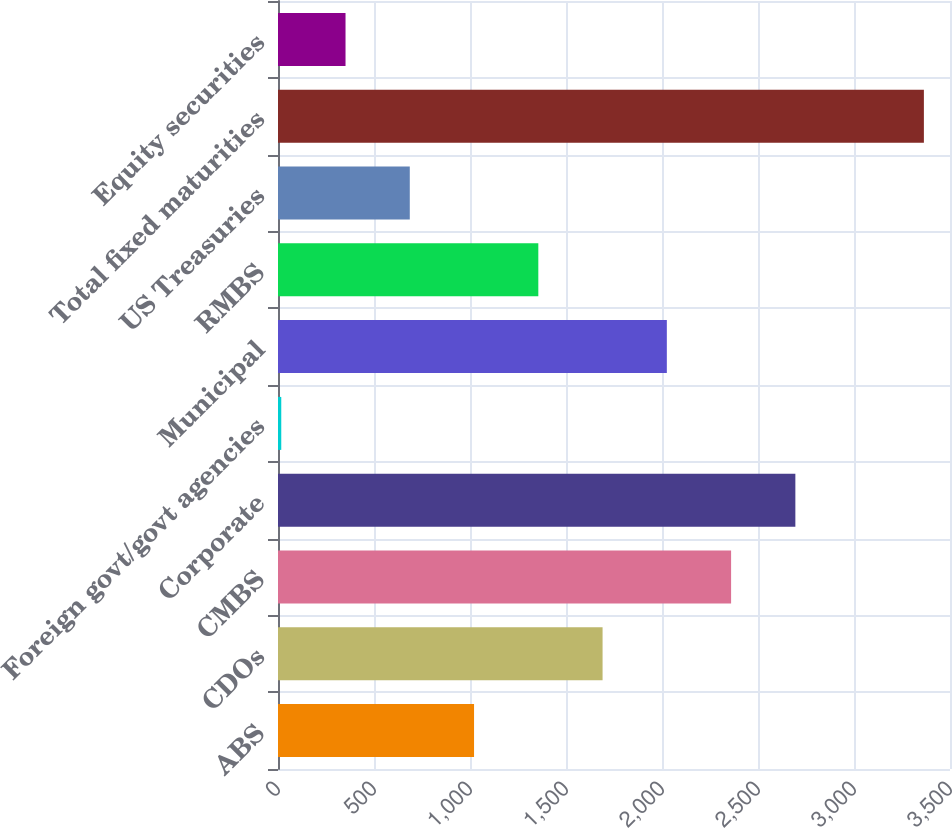Convert chart. <chart><loc_0><loc_0><loc_500><loc_500><bar_chart><fcel>ABS<fcel>CDOs<fcel>CMBS<fcel>Corporate<fcel>Foreign govt/govt agencies<fcel>Municipal<fcel>RMBS<fcel>US Treasuries<fcel>Total fixed maturities<fcel>Equity securities<nl><fcel>1021.1<fcel>1690.5<fcel>2359.9<fcel>2694.6<fcel>17<fcel>2025.2<fcel>1355.8<fcel>686.4<fcel>3364<fcel>351.7<nl></chart> 